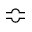<formula> <loc_0><loc_0><loc_500><loc_500>\ B u m p e q</formula> 